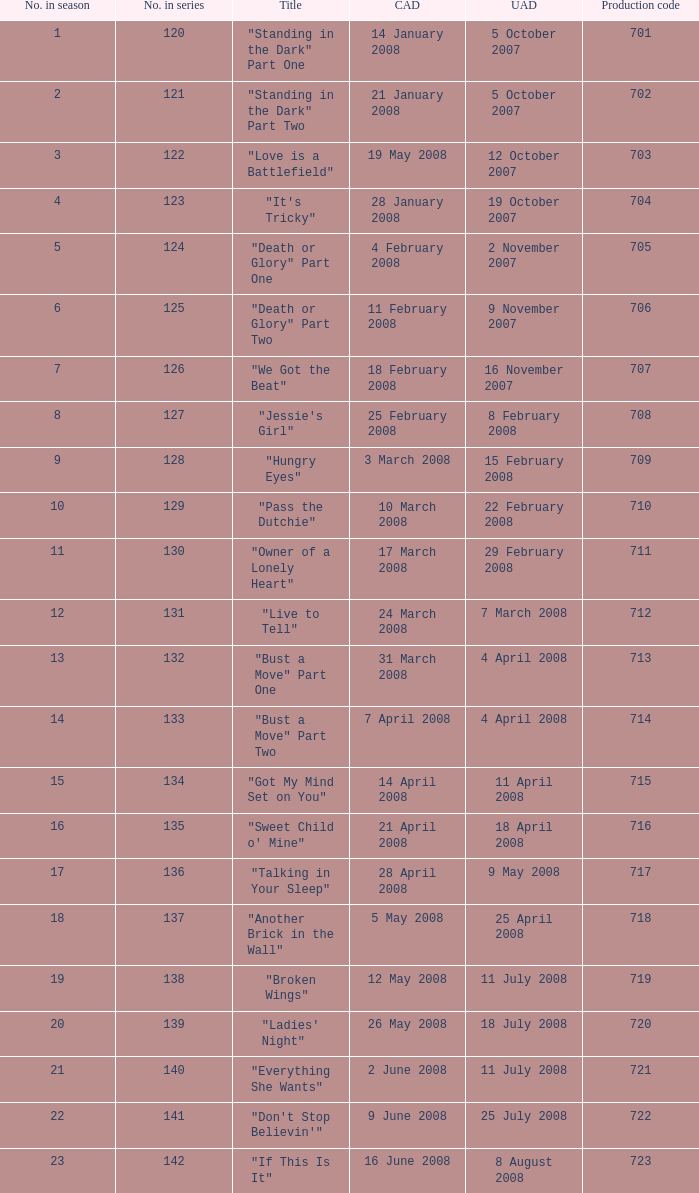The canadian airdate of 11 february 2008 applied to what series number? 1.0. 